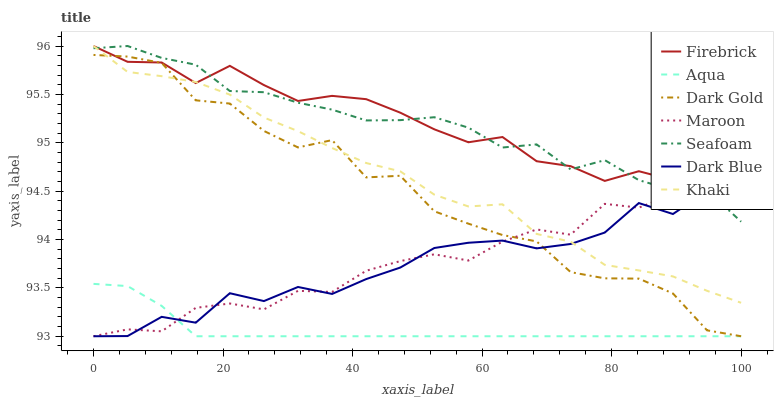Does Aqua have the minimum area under the curve?
Answer yes or no. Yes. Does Firebrick have the maximum area under the curve?
Answer yes or no. Yes. Does Dark Gold have the minimum area under the curve?
Answer yes or no. No. Does Dark Gold have the maximum area under the curve?
Answer yes or no. No. Is Aqua the smoothest?
Answer yes or no. Yes. Is Dark Gold the roughest?
Answer yes or no. Yes. Is Firebrick the smoothest?
Answer yes or no. No. Is Firebrick the roughest?
Answer yes or no. No. Does Dark Gold have the lowest value?
Answer yes or no. Yes. Does Firebrick have the lowest value?
Answer yes or no. No. Does Seafoam have the highest value?
Answer yes or no. Yes. Does Dark Gold have the highest value?
Answer yes or no. No. Is Aqua less than Seafoam?
Answer yes or no. Yes. Is Seafoam greater than Aqua?
Answer yes or no. Yes. Does Dark Blue intersect Seafoam?
Answer yes or no. Yes. Is Dark Blue less than Seafoam?
Answer yes or no. No. Is Dark Blue greater than Seafoam?
Answer yes or no. No. Does Aqua intersect Seafoam?
Answer yes or no. No. 